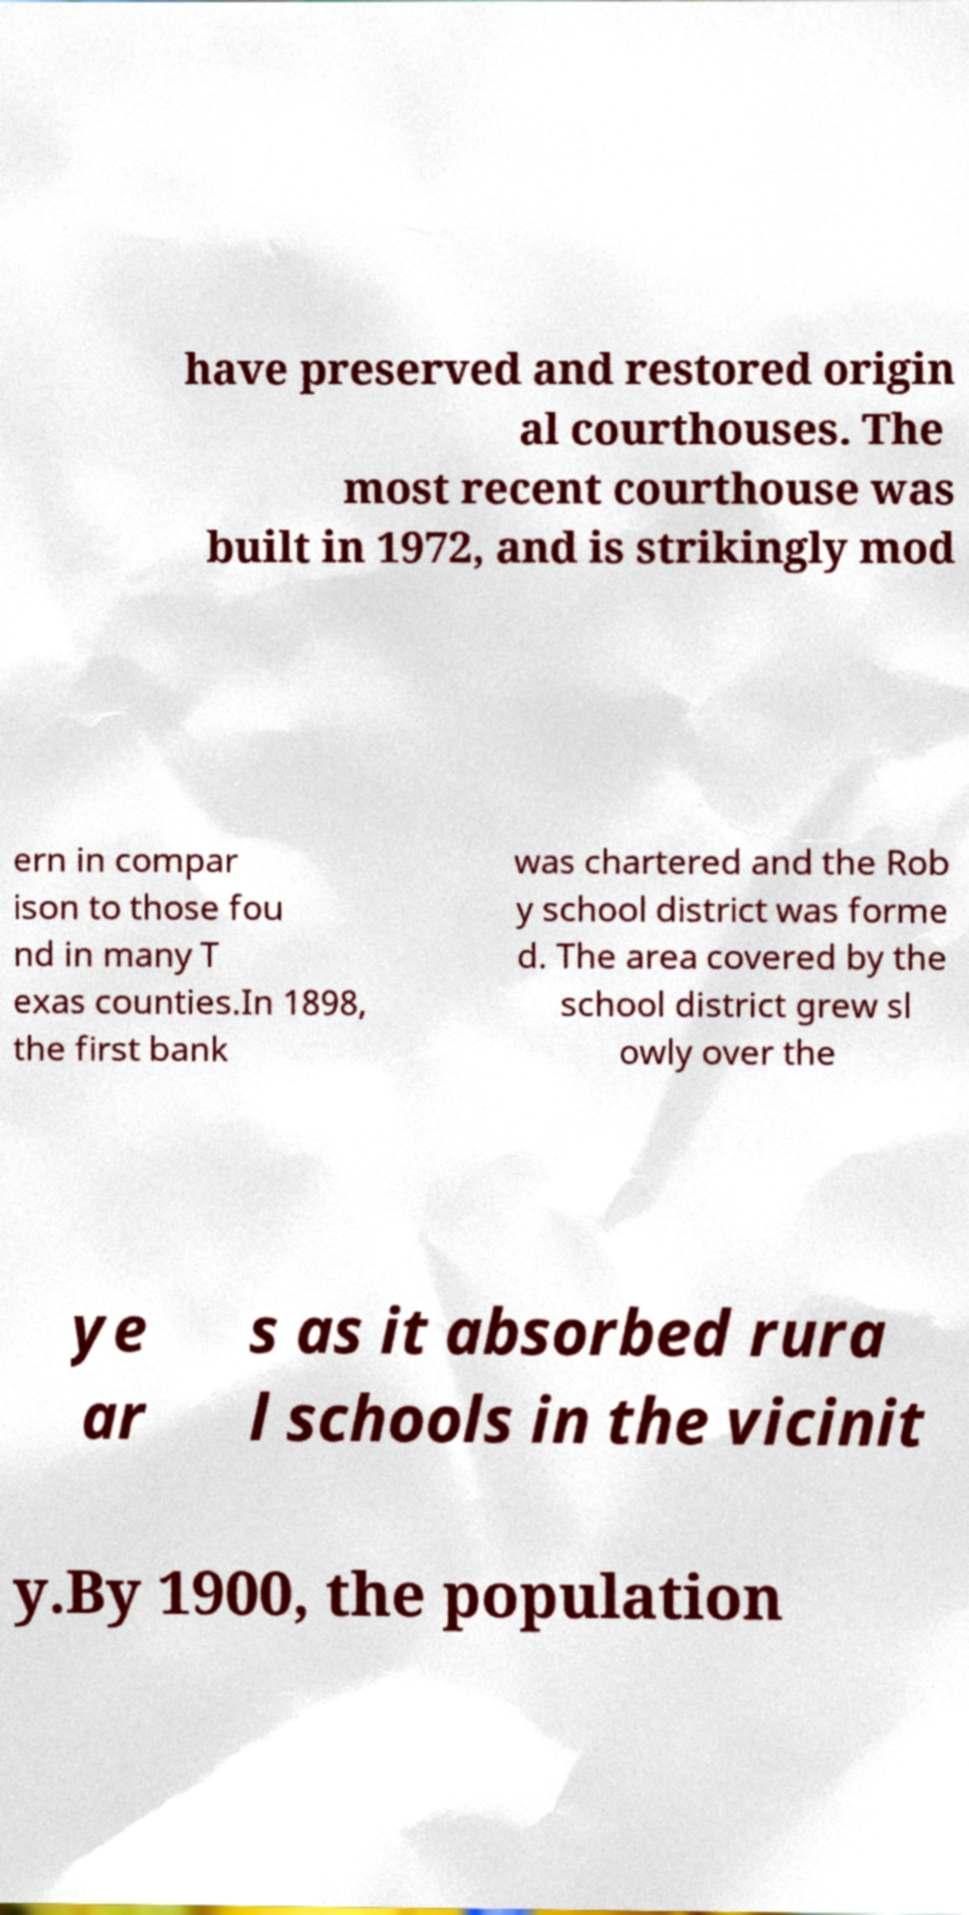Please identify and transcribe the text found in this image. have preserved and restored origin al courthouses. The most recent courthouse was built in 1972, and is strikingly mod ern in compar ison to those fou nd in many T exas counties.In 1898, the first bank was chartered and the Rob y school district was forme d. The area covered by the school district grew sl owly over the ye ar s as it absorbed rura l schools in the vicinit y.By 1900, the population 